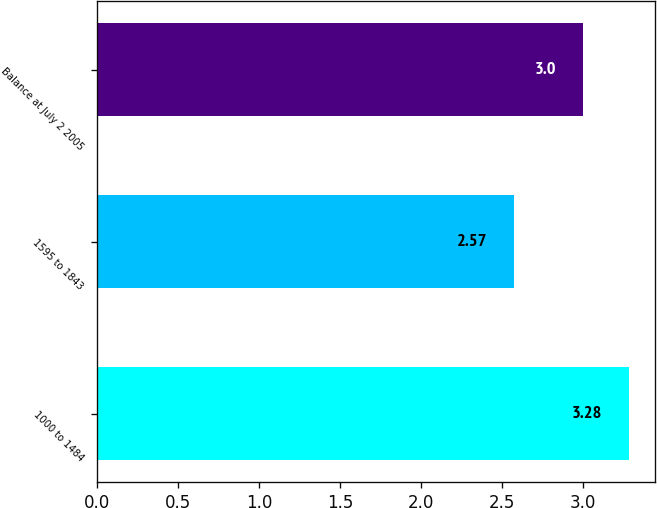Convert chart. <chart><loc_0><loc_0><loc_500><loc_500><bar_chart><fcel>1000 to 1484<fcel>1595 to 1843<fcel>Balance at July 2 2005<nl><fcel>3.28<fcel>2.57<fcel>3<nl></chart> 